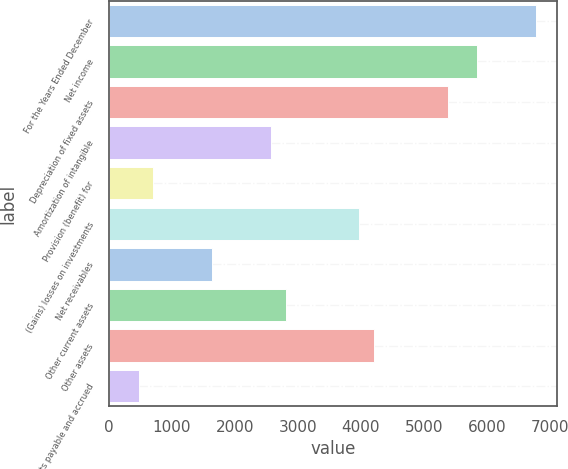Convert chart. <chart><loc_0><loc_0><loc_500><loc_500><bar_chart><fcel>For the Years Ended December<fcel>Net income<fcel>Depreciation of fixed assets<fcel>Amortization of intangible<fcel>Provision (benefit) for<fcel>(Gains) losses on investments<fcel>Net receivables<fcel>Other current assets<fcel>Other assets<fcel>Accounts payable and accrued<nl><fcel>6781.3<fcel>5846.5<fcel>5379.1<fcel>2574.7<fcel>705.1<fcel>3976.9<fcel>1639.9<fcel>2808.4<fcel>4210.6<fcel>471.4<nl></chart> 